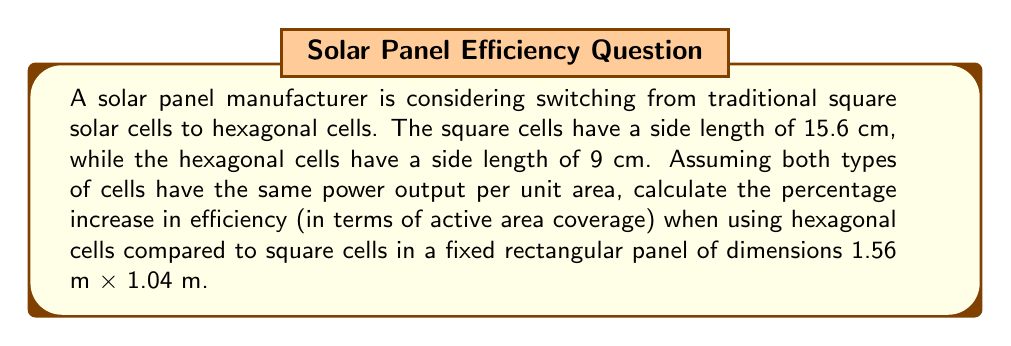Solve this math problem. Let's approach this step-by-step:

1. Calculate the area of a single square cell:
   $$A_{square} = 15.6 \text{ cm} \times 15.6 \text{ cm} = 243.36 \text{ cm}^2$$

2. Calculate the area of a single hexagonal cell:
   $$A_{hexagon} = \frac{3\sqrt{3}}{2} \times 9^2 \text{ cm}^2 = 210.47 \text{ cm}^2$$

3. Calculate the number of square cells that fit in the panel:
   - Horizontally: $156 \text{ cm} \div 15.6 \text{ cm} = 10$ cells
   - Vertically: $104 \text{ cm} \div 15.6 \text{ cm} = 6.67$ cells (rounded to 6)
   Total square cells: $10 \times 6 = 60$ cells

4. Calculate the total area covered by square cells:
   $$A_{total\_square} = 60 \times 243.36 \text{ cm}^2 = 14,601.6 \text{ cm}^2$$

5. For hexagonal cells, we need to calculate how many fit in the panel:
   [asy]
   unitsize(1cm);
   real a = 9;
   real h = a * sqrt(3)/2;
   path hex = (a,0)--(a/2,h)--(-a/2,h)--(-a,-0)--(-a/2,-h)--(a/2,-h)--cycle;
   for(int i = 0; i < 9; ++i) {
     for(int j = 0; j < 6; ++j) {
       draw(shift(i*1.5*a, j*2*h + (i%2)*h)*hex);
     }
   }
   [/asy]

   - Horizontally: $156 \text{ cm} \div (1.5 \times 9 \text{ cm}) = 11.56$ (rounded to 11)
   - Vertically: $104 \text{ cm} \div (2 \times 9 \text{ cm} \times \sqrt{3}/2) = 6.67$ (rounded to 6)
   Total hexagonal cells: $11 \times 6 + 5 = 71$ cells (including partial row)

6. Calculate the total area covered by hexagonal cells:
   $$A_{total\_hexagon} = 71 \times 210.47 \text{ cm}^2 = 14,943.37 \text{ cm}^2$$

7. Calculate the percentage increase in efficiency:
   $$\text{Efficiency increase} = \frac{A_{total\_hexagon} - A_{total\_square}}{A_{total\_square}} \times 100\%$$
   $$= \frac{14,943.37 - 14,601.6}{14,601.6} \times 100\% = 2.34\%$$

Therefore, switching to hexagonal cells increases the efficiency by 2.34% in terms of active area coverage.
Answer: 2.34% 